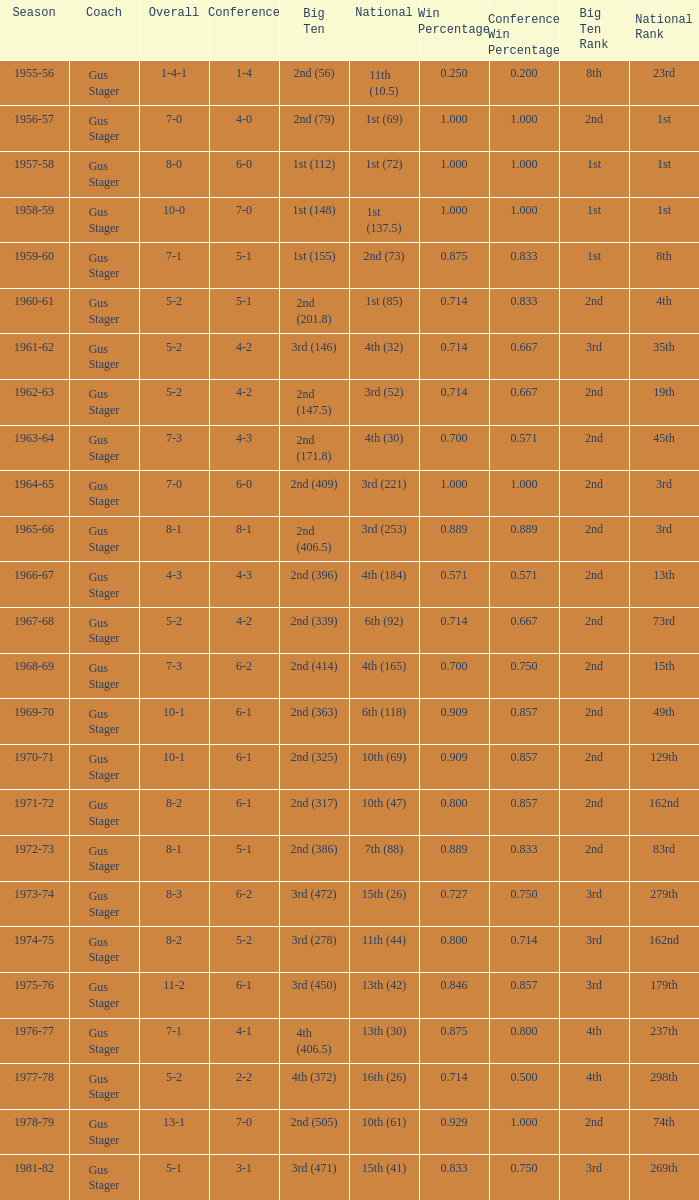What is the Coach with a Big Ten that is 3rd (278)? Gus Stager. 